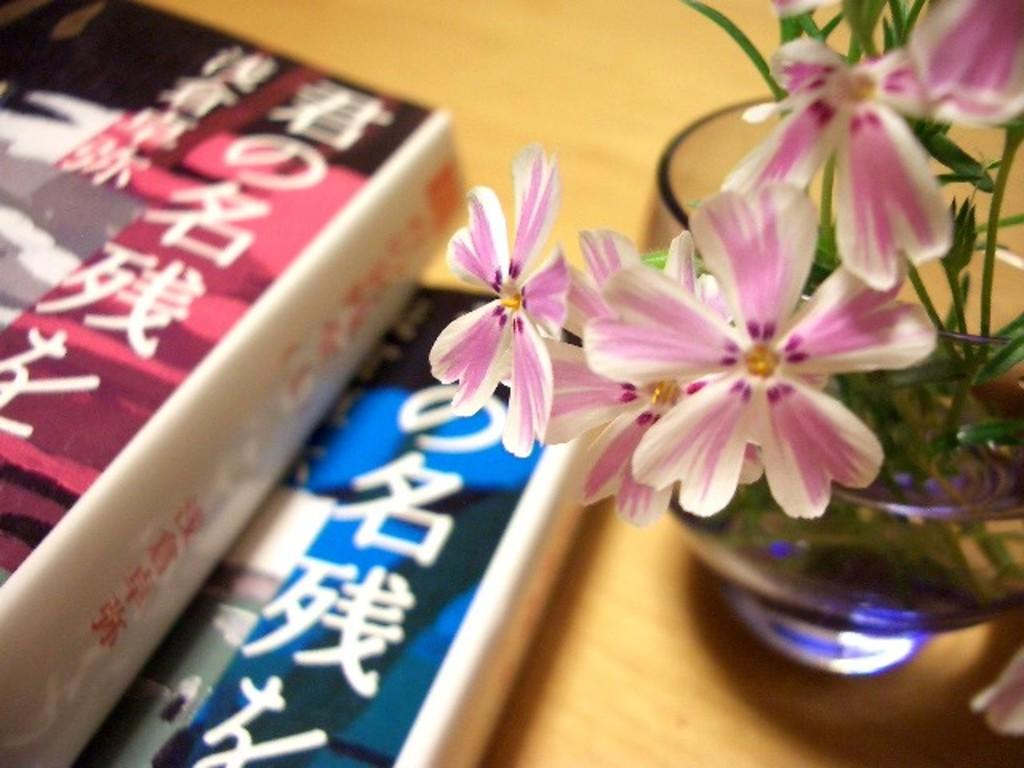What objects can be seen in the image? There are books and a flower vase on the table in the image. What is written on the books? The books have text on them. What type of flowers are in the flower vase? The flower vase contains white and pink flowers. What type of basket is being used to hold the invention in the image? There is no basket or invention present in the image. 